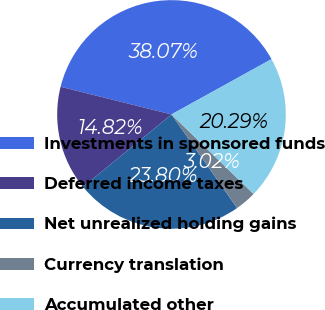<chart> <loc_0><loc_0><loc_500><loc_500><pie_chart><fcel>Investments in sponsored funds<fcel>Deferred income taxes<fcel>Net unrealized holding gains<fcel>Currency translation<fcel>Accumulated other<nl><fcel>38.07%<fcel>14.82%<fcel>23.8%<fcel>3.02%<fcel>20.29%<nl></chart> 